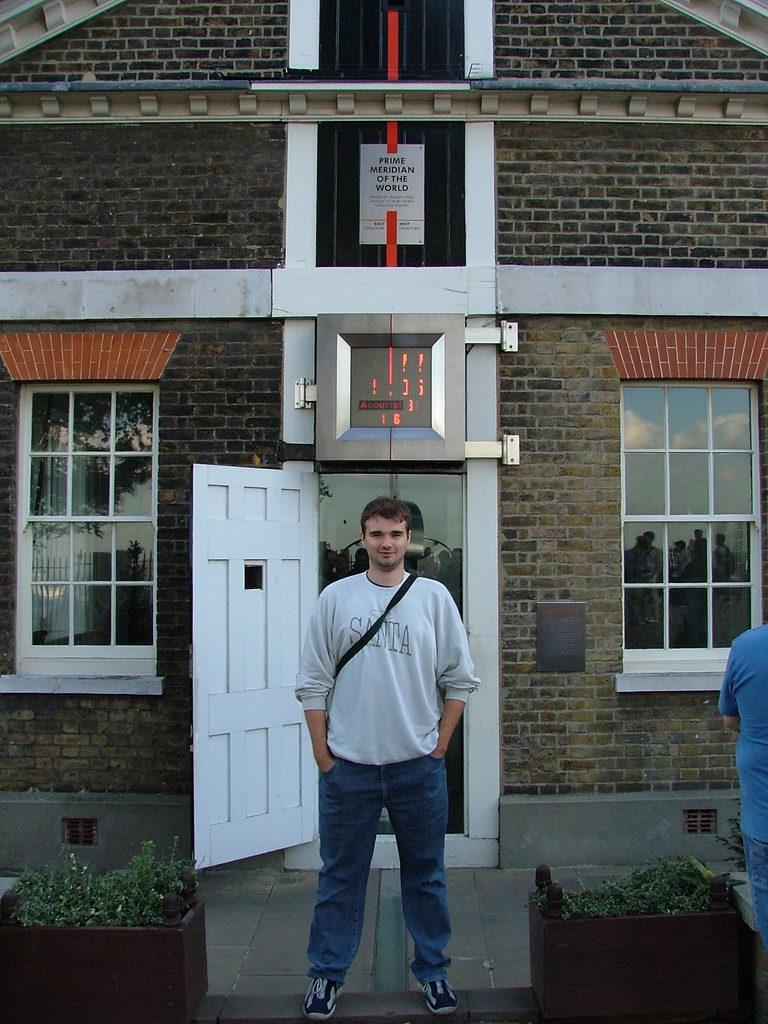<image>
Give a short and clear explanation of the subsequent image. Man wearing a sweater that says SANTA on it in front of a house. 